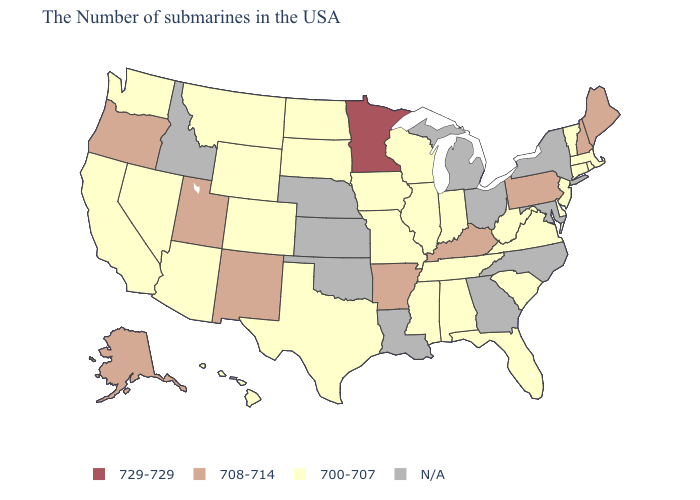Does Massachusetts have the lowest value in the USA?
Concise answer only. Yes. Which states have the highest value in the USA?
Keep it brief. Minnesota. Which states have the highest value in the USA?
Answer briefly. Minnesota. Name the states that have a value in the range 700-707?
Concise answer only. Massachusetts, Rhode Island, Vermont, Connecticut, New Jersey, Delaware, Virginia, South Carolina, West Virginia, Florida, Indiana, Alabama, Tennessee, Wisconsin, Illinois, Mississippi, Missouri, Iowa, Texas, South Dakota, North Dakota, Wyoming, Colorado, Montana, Arizona, Nevada, California, Washington, Hawaii. Which states have the highest value in the USA?
Concise answer only. Minnesota. Name the states that have a value in the range 708-714?
Write a very short answer. Maine, New Hampshire, Pennsylvania, Kentucky, Arkansas, New Mexico, Utah, Oregon, Alaska. Among the states that border Pennsylvania , which have the highest value?
Be succinct. New Jersey, Delaware, West Virginia. Does Arkansas have the highest value in the South?
Concise answer only. Yes. Name the states that have a value in the range 708-714?
Write a very short answer. Maine, New Hampshire, Pennsylvania, Kentucky, Arkansas, New Mexico, Utah, Oregon, Alaska. Does the first symbol in the legend represent the smallest category?
Concise answer only. No. Which states have the highest value in the USA?
Quick response, please. Minnesota. Is the legend a continuous bar?
Quick response, please. No. Name the states that have a value in the range N/A?
Short answer required. New York, Maryland, North Carolina, Ohio, Georgia, Michigan, Louisiana, Kansas, Nebraska, Oklahoma, Idaho. 